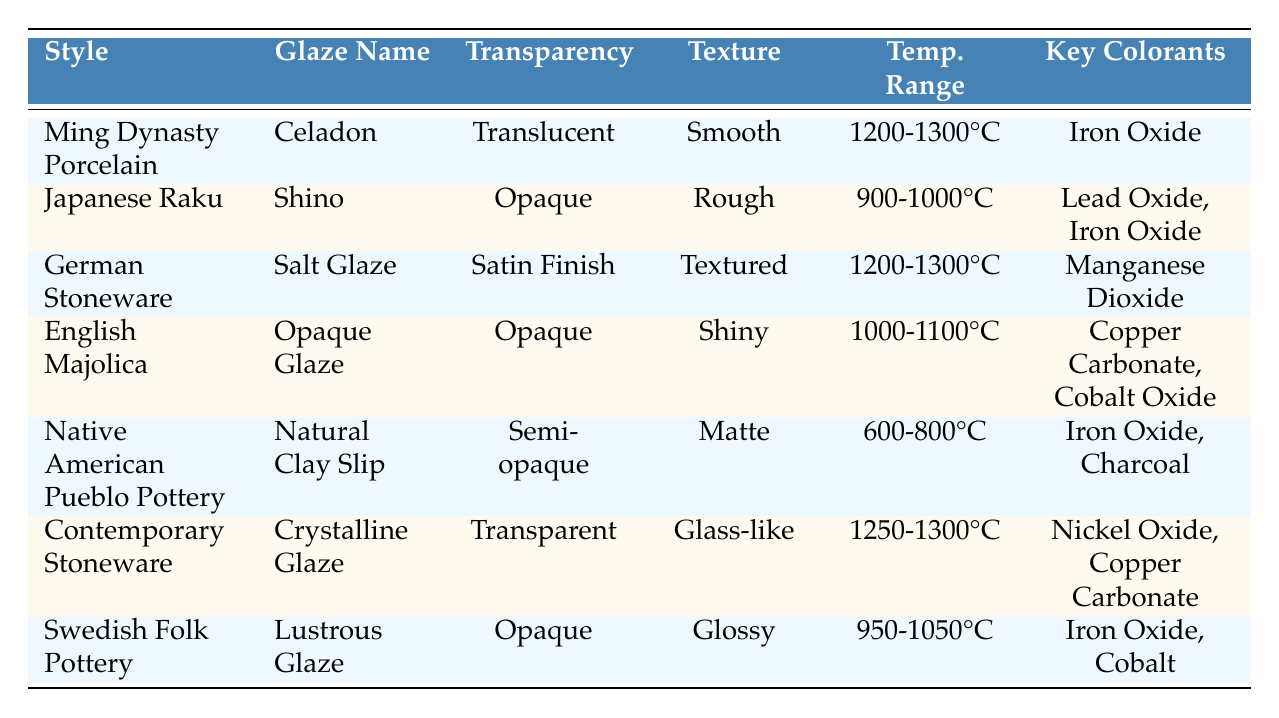What is the temperature range for Japanese Raku glazes? The table lists the temperature range for Japanese Raku, specifically for the Shino glaze, as 900-1000°C.
Answer: 900-1000°C Which glaze has a translucent property? Looking at the table, the only glaze described as translucent is the Celadon from Ming Dynasty Porcelain.
Answer: Celadon How many styles have opaque glazes? By examining the table, we can see that both Japanese Raku (Shino), English Majolica (Opaque Glaze), Swedish Folk Pottery (Lustrous Glaze), and one more, making it four in total.
Answer: Four What colorant is common between Native American Pueblo Pottery and Swedish Folk Pottery? Both glaze formulations include Iron Oxide as a colorant, which can be verified by inspecting the respective rows in the table.
Answer: Iron Oxide Is the texture of the Crystalline Glaze smooth? From the table, the texture of the Crystalline Glaze from Contemporary Stoneware is noted as glass-like, not smooth, which confirms the answer is no.
Answer: No What is the historical significance of German Stoneware? The table states that German Stoneware's Salt Glaze origin traces back to a traditional method originating in the late 15th century.
Answer: A traditional method originating in the late 15th century Which glaze has the highest firing temperature? Looking at the temperature ranges provided, both Celadon and Salt Glaze require a temperature of 1200-1300°C, which is the highest among the listed glazes.
Answer: Celadon and Salt Glaze What is the average temperature range for glazes with opaque transparency? The ranges for the opaque glazes are 900-1000°C (Shino), 1000-1100°C (Opaque Glaze), and 950-1050°C (Lustrous Glaze). The average of (950 + 1000 + 1100) / 3 = 1025°C.
Answer: 1025°C Is it true that all glazes listed are opaque? The table reveals that not all glazes are opaque; for instance, the Celadon glaze is translucent and the Crystalline Glaze is transparent. This means the statement is false.
Answer: False How does the texture of Shino compare with that of Lustrous Glaze? By reviewing the table, Shino has a rough texture while Lustrous Glaze is described as glossy, indicating they differ in texture.
Answer: They differ in texture Which pottery style uses Nickel Oxide as a colorant? The table identifies Nickel Oxide as a colorant used in the Crystalline Glaze from Contemporary Stoneware.
Answer: Contemporary Stoneware 